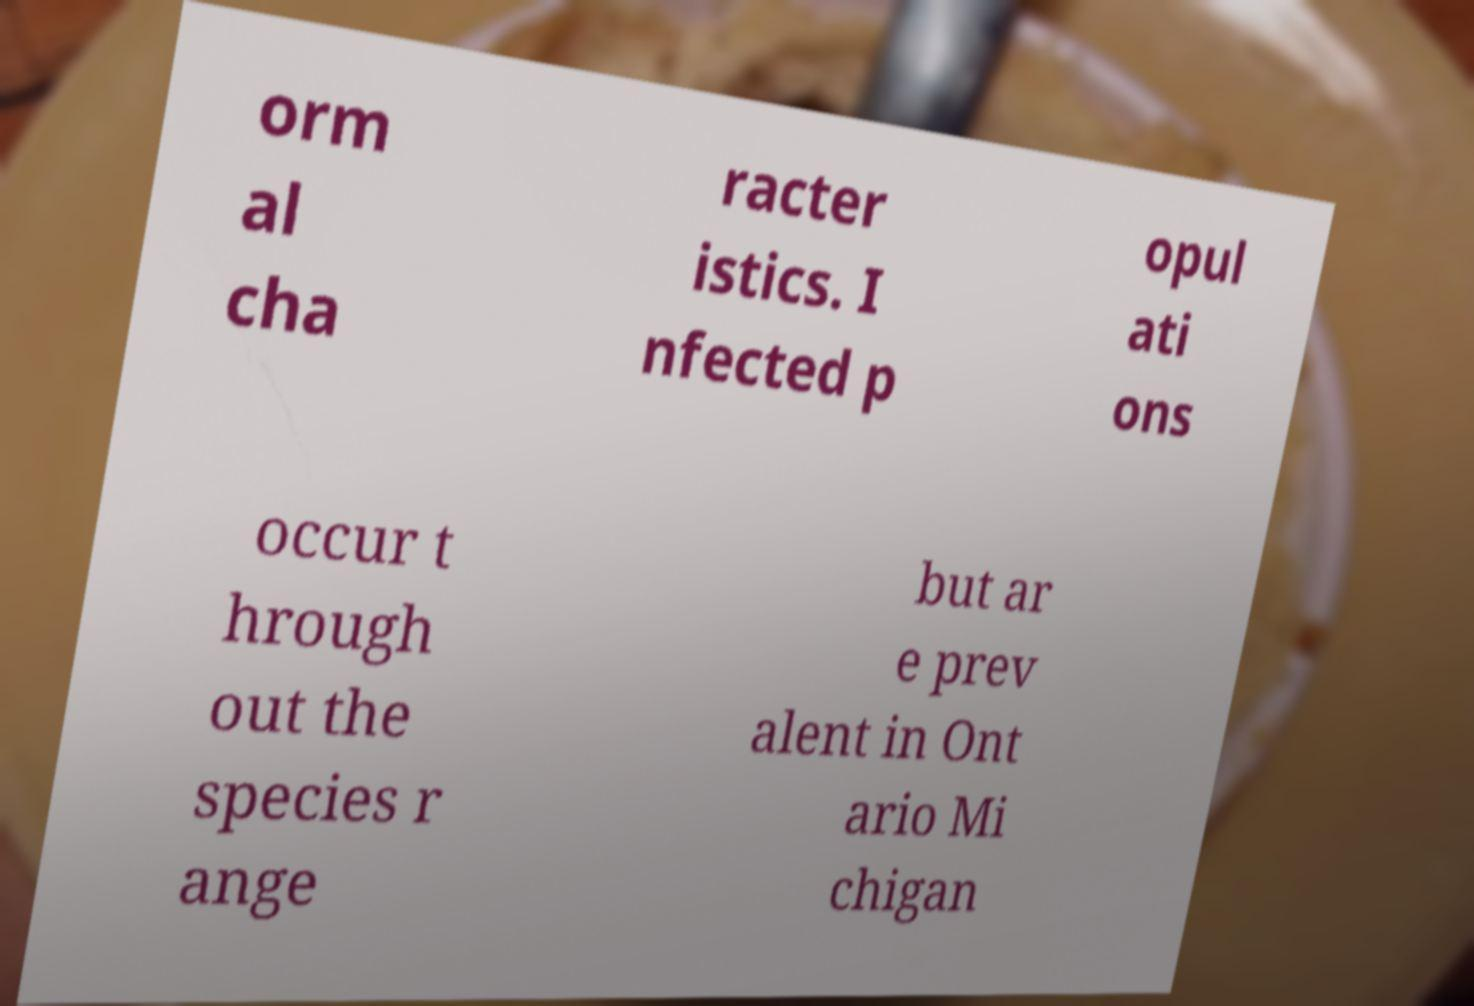Can you read and provide the text displayed in the image?This photo seems to have some interesting text. Can you extract and type it out for me? orm al cha racter istics. I nfected p opul ati ons occur t hrough out the species r ange but ar e prev alent in Ont ario Mi chigan 